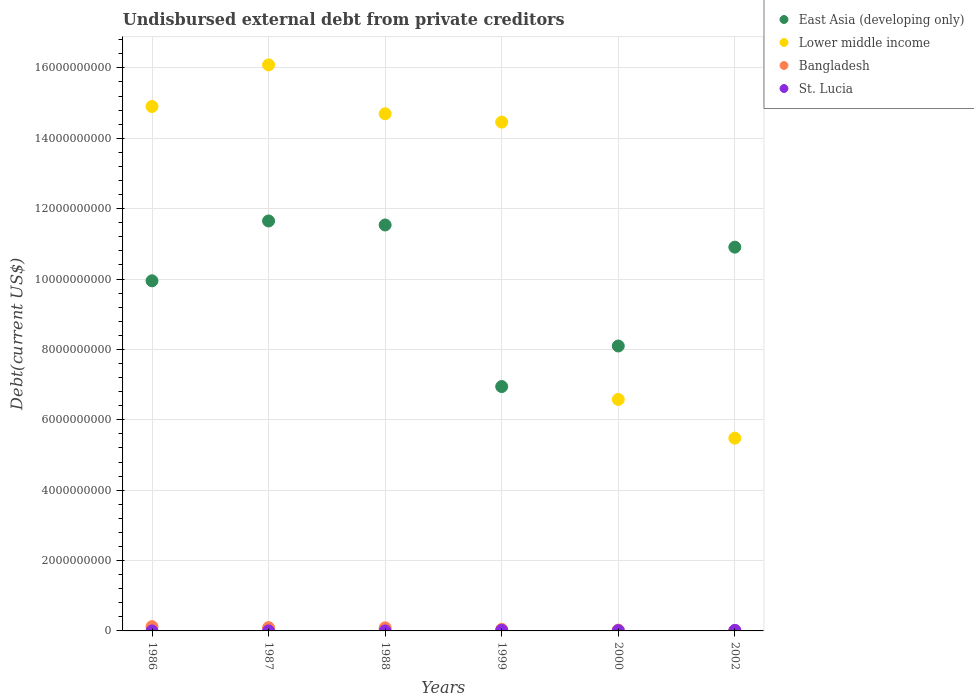How many different coloured dotlines are there?
Give a very brief answer. 4. Is the number of dotlines equal to the number of legend labels?
Give a very brief answer. Yes. What is the total debt in St. Lucia in 1987?
Your answer should be very brief. 4.15e+05. Across all years, what is the maximum total debt in St. Lucia?
Provide a short and direct response. 1.74e+07. Across all years, what is the minimum total debt in Lower middle income?
Your answer should be compact. 5.48e+09. What is the total total debt in Lower middle income in the graph?
Your answer should be compact. 7.22e+1. What is the difference between the total debt in Bangladesh in 1988 and that in 2000?
Make the answer very short. 6.29e+07. What is the difference between the total debt in Lower middle income in 1988 and the total debt in St. Lucia in 1986?
Provide a short and direct response. 1.47e+1. What is the average total debt in St. Lucia per year?
Provide a succinct answer. 7.09e+06. In the year 1999, what is the difference between the total debt in St. Lucia and total debt in Lower middle income?
Make the answer very short. -1.44e+1. What is the ratio of the total debt in St. Lucia in 1986 to that in 1988?
Keep it short and to the point. 0.81. What is the difference between the highest and the second highest total debt in Bangladesh?
Make the answer very short. 2.77e+07. What is the difference between the highest and the lowest total debt in East Asia (developing only)?
Offer a terse response. 4.71e+09. In how many years, is the total debt in St. Lucia greater than the average total debt in St. Lucia taken over all years?
Offer a very short reply. 3. Is the sum of the total debt in Lower middle income in 1986 and 2002 greater than the maximum total debt in East Asia (developing only) across all years?
Offer a terse response. Yes. Is it the case that in every year, the sum of the total debt in St. Lucia and total debt in Lower middle income  is greater than the total debt in East Asia (developing only)?
Provide a succinct answer. No. Is the total debt in East Asia (developing only) strictly less than the total debt in Lower middle income over the years?
Provide a succinct answer. No. What is the difference between two consecutive major ticks on the Y-axis?
Give a very brief answer. 2.00e+09. Are the values on the major ticks of Y-axis written in scientific E-notation?
Your response must be concise. No. Does the graph contain grids?
Make the answer very short. Yes. How are the legend labels stacked?
Provide a short and direct response. Vertical. What is the title of the graph?
Keep it short and to the point. Undisbursed external debt from private creditors. Does "St. Kitts and Nevis" appear as one of the legend labels in the graph?
Your response must be concise. No. What is the label or title of the Y-axis?
Make the answer very short. Debt(current US$). What is the Debt(current US$) of East Asia (developing only) in 1986?
Make the answer very short. 9.95e+09. What is the Debt(current US$) of Lower middle income in 1986?
Provide a succinct answer. 1.49e+1. What is the Debt(current US$) of Bangladesh in 1986?
Provide a short and direct response. 1.21e+08. What is the Debt(current US$) in St. Lucia in 1986?
Offer a terse response. 3.27e+05. What is the Debt(current US$) of East Asia (developing only) in 1987?
Your answer should be very brief. 1.16e+1. What is the Debt(current US$) of Lower middle income in 1987?
Your response must be concise. 1.61e+1. What is the Debt(current US$) of Bangladesh in 1987?
Offer a terse response. 9.33e+07. What is the Debt(current US$) of St. Lucia in 1987?
Your response must be concise. 4.15e+05. What is the Debt(current US$) of East Asia (developing only) in 1988?
Keep it short and to the point. 1.15e+1. What is the Debt(current US$) in Lower middle income in 1988?
Offer a terse response. 1.47e+1. What is the Debt(current US$) of Bangladesh in 1988?
Ensure brevity in your answer.  8.73e+07. What is the Debt(current US$) in St. Lucia in 1988?
Provide a succinct answer. 4.02e+05. What is the Debt(current US$) of East Asia (developing only) in 1999?
Provide a short and direct response. 6.94e+09. What is the Debt(current US$) of Lower middle income in 1999?
Your answer should be very brief. 1.45e+1. What is the Debt(current US$) in Bangladesh in 1999?
Your response must be concise. 4.35e+07. What is the Debt(current US$) of St. Lucia in 1999?
Offer a very short reply. 1.74e+07. What is the Debt(current US$) of East Asia (developing only) in 2000?
Keep it short and to the point. 8.10e+09. What is the Debt(current US$) of Lower middle income in 2000?
Offer a very short reply. 6.58e+09. What is the Debt(current US$) of Bangladesh in 2000?
Offer a very short reply. 2.44e+07. What is the Debt(current US$) in St. Lucia in 2000?
Provide a short and direct response. 9.00e+06. What is the Debt(current US$) in East Asia (developing only) in 2002?
Give a very brief answer. 1.09e+1. What is the Debt(current US$) of Lower middle income in 2002?
Ensure brevity in your answer.  5.48e+09. What is the Debt(current US$) in Bangladesh in 2002?
Keep it short and to the point. 1.15e+07. What is the Debt(current US$) in St. Lucia in 2002?
Give a very brief answer. 1.50e+07. Across all years, what is the maximum Debt(current US$) in East Asia (developing only)?
Give a very brief answer. 1.16e+1. Across all years, what is the maximum Debt(current US$) of Lower middle income?
Your answer should be very brief. 1.61e+1. Across all years, what is the maximum Debt(current US$) of Bangladesh?
Keep it short and to the point. 1.21e+08. Across all years, what is the maximum Debt(current US$) of St. Lucia?
Give a very brief answer. 1.74e+07. Across all years, what is the minimum Debt(current US$) of East Asia (developing only)?
Make the answer very short. 6.94e+09. Across all years, what is the minimum Debt(current US$) of Lower middle income?
Provide a succinct answer. 5.48e+09. Across all years, what is the minimum Debt(current US$) of Bangladesh?
Provide a succinct answer. 1.15e+07. Across all years, what is the minimum Debt(current US$) in St. Lucia?
Keep it short and to the point. 3.27e+05. What is the total Debt(current US$) in East Asia (developing only) in the graph?
Keep it short and to the point. 5.91e+1. What is the total Debt(current US$) of Lower middle income in the graph?
Ensure brevity in your answer.  7.22e+1. What is the total Debt(current US$) of Bangladesh in the graph?
Ensure brevity in your answer.  3.81e+08. What is the total Debt(current US$) in St. Lucia in the graph?
Keep it short and to the point. 4.25e+07. What is the difference between the Debt(current US$) of East Asia (developing only) in 1986 and that in 1987?
Your response must be concise. -1.70e+09. What is the difference between the Debt(current US$) of Lower middle income in 1986 and that in 1987?
Your response must be concise. -1.18e+09. What is the difference between the Debt(current US$) in Bangladesh in 1986 and that in 1987?
Provide a succinct answer. 2.77e+07. What is the difference between the Debt(current US$) in St. Lucia in 1986 and that in 1987?
Offer a very short reply. -8.80e+04. What is the difference between the Debt(current US$) in East Asia (developing only) in 1986 and that in 1988?
Offer a very short reply. -1.59e+09. What is the difference between the Debt(current US$) of Lower middle income in 1986 and that in 1988?
Provide a short and direct response. 2.07e+08. What is the difference between the Debt(current US$) in Bangladesh in 1986 and that in 1988?
Give a very brief answer. 3.37e+07. What is the difference between the Debt(current US$) in St. Lucia in 1986 and that in 1988?
Make the answer very short. -7.50e+04. What is the difference between the Debt(current US$) in East Asia (developing only) in 1986 and that in 1999?
Offer a terse response. 3.00e+09. What is the difference between the Debt(current US$) in Lower middle income in 1986 and that in 1999?
Offer a terse response. 4.43e+08. What is the difference between the Debt(current US$) of Bangladesh in 1986 and that in 1999?
Your response must be concise. 7.75e+07. What is the difference between the Debt(current US$) of St. Lucia in 1986 and that in 1999?
Make the answer very short. -1.71e+07. What is the difference between the Debt(current US$) of East Asia (developing only) in 1986 and that in 2000?
Keep it short and to the point. 1.85e+09. What is the difference between the Debt(current US$) of Lower middle income in 1986 and that in 2000?
Your answer should be very brief. 8.32e+09. What is the difference between the Debt(current US$) in Bangladesh in 1986 and that in 2000?
Ensure brevity in your answer.  9.66e+07. What is the difference between the Debt(current US$) of St. Lucia in 1986 and that in 2000?
Make the answer very short. -8.67e+06. What is the difference between the Debt(current US$) of East Asia (developing only) in 1986 and that in 2002?
Offer a very short reply. -9.57e+08. What is the difference between the Debt(current US$) in Lower middle income in 1986 and that in 2002?
Provide a succinct answer. 9.42e+09. What is the difference between the Debt(current US$) of Bangladesh in 1986 and that in 2002?
Give a very brief answer. 1.09e+08. What is the difference between the Debt(current US$) of St. Lucia in 1986 and that in 2002?
Ensure brevity in your answer.  -1.47e+07. What is the difference between the Debt(current US$) in East Asia (developing only) in 1987 and that in 1988?
Make the answer very short. 1.14e+08. What is the difference between the Debt(current US$) of Lower middle income in 1987 and that in 1988?
Ensure brevity in your answer.  1.39e+09. What is the difference between the Debt(current US$) of St. Lucia in 1987 and that in 1988?
Provide a succinct answer. 1.30e+04. What is the difference between the Debt(current US$) of East Asia (developing only) in 1987 and that in 1999?
Provide a succinct answer. 4.71e+09. What is the difference between the Debt(current US$) in Lower middle income in 1987 and that in 1999?
Provide a succinct answer. 1.63e+09. What is the difference between the Debt(current US$) in Bangladesh in 1987 and that in 1999?
Offer a very short reply. 4.98e+07. What is the difference between the Debt(current US$) of St. Lucia in 1987 and that in 1999?
Ensure brevity in your answer.  -1.70e+07. What is the difference between the Debt(current US$) of East Asia (developing only) in 1987 and that in 2000?
Ensure brevity in your answer.  3.55e+09. What is the difference between the Debt(current US$) of Lower middle income in 1987 and that in 2000?
Offer a terse response. 9.51e+09. What is the difference between the Debt(current US$) in Bangladesh in 1987 and that in 2000?
Your response must be concise. 6.89e+07. What is the difference between the Debt(current US$) in St. Lucia in 1987 and that in 2000?
Give a very brief answer. -8.58e+06. What is the difference between the Debt(current US$) of East Asia (developing only) in 1987 and that in 2002?
Make the answer very short. 7.45e+08. What is the difference between the Debt(current US$) in Lower middle income in 1987 and that in 2002?
Offer a very short reply. 1.06e+1. What is the difference between the Debt(current US$) in Bangladesh in 1987 and that in 2002?
Your answer should be very brief. 8.18e+07. What is the difference between the Debt(current US$) of St. Lucia in 1987 and that in 2002?
Make the answer very short. -1.46e+07. What is the difference between the Debt(current US$) of East Asia (developing only) in 1988 and that in 1999?
Offer a terse response. 4.59e+09. What is the difference between the Debt(current US$) in Lower middle income in 1988 and that in 1999?
Provide a short and direct response. 2.37e+08. What is the difference between the Debt(current US$) of Bangladesh in 1988 and that in 1999?
Offer a very short reply. 4.38e+07. What is the difference between the Debt(current US$) of St. Lucia in 1988 and that in 1999?
Keep it short and to the point. -1.70e+07. What is the difference between the Debt(current US$) of East Asia (developing only) in 1988 and that in 2000?
Your answer should be compact. 3.44e+09. What is the difference between the Debt(current US$) of Lower middle income in 1988 and that in 2000?
Your response must be concise. 8.12e+09. What is the difference between the Debt(current US$) of Bangladesh in 1988 and that in 2000?
Offer a very short reply. 6.29e+07. What is the difference between the Debt(current US$) in St. Lucia in 1988 and that in 2000?
Your answer should be compact. -8.60e+06. What is the difference between the Debt(current US$) in East Asia (developing only) in 1988 and that in 2002?
Keep it short and to the point. 6.30e+08. What is the difference between the Debt(current US$) in Lower middle income in 1988 and that in 2002?
Your answer should be compact. 9.22e+09. What is the difference between the Debt(current US$) of Bangladesh in 1988 and that in 2002?
Offer a terse response. 7.58e+07. What is the difference between the Debt(current US$) of St. Lucia in 1988 and that in 2002?
Your response must be concise. -1.46e+07. What is the difference between the Debt(current US$) of East Asia (developing only) in 1999 and that in 2000?
Your response must be concise. -1.15e+09. What is the difference between the Debt(current US$) of Lower middle income in 1999 and that in 2000?
Your answer should be compact. 7.88e+09. What is the difference between the Debt(current US$) in Bangladesh in 1999 and that in 2000?
Your answer should be very brief. 1.91e+07. What is the difference between the Debt(current US$) in St. Lucia in 1999 and that in 2000?
Your answer should be compact. 8.40e+06. What is the difference between the Debt(current US$) in East Asia (developing only) in 1999 and that in 2002?
Keep it short and to the point. -3.96e+09. What is the difference between the Debt(current US$) in Lower middle income in 1999 and that in 2002?
Keep it short and to the point. 8.98e+09. What is the difference between the Debt(current US$) of Bangladesh in 1999 and that in 2002?
Make the answer very short. 3.20e+07. What is the difference between the Debt(current US$) of St. Lucia in 1999 and that in 2002?
Provide a succinct answer. 2.40e+06. What is the difference between the Debt(current US$) of East Asia (developing only) in 2000 and that in 2002?
Your answer should be compact. -2.81e+09. What is the difference between the Debt(current US$) in Lower middle income in 2000 and that in 2002?
Give a very brief answer. 1.10e+09. What is the difference between the Debt(current US$) in Bangladesh in 2000 and that in 2002?
Your answer should be compact. 1.29e+07. What is the difference between the Debt(current US$) of St. Lucia in 2000 and that in 2002?
Ensure brevity in your answer.  -6.00e+06. What is the difference between the Debt(current US$) in East Asia (developing only) in 1986 and the Debt(current US$) in Lower middle income in 1987?
Your answer should be compact. -6.14e+09. What is the difference between the Debt(current US$) in East Asia (developing only) in 1986 and the Debt(current US$) in Bangladesh in 1987?
Offer a terse response. 9.86e+09. What is the difference between the Debt(current US$) in East Asia (developing only) in 1986 and the Debt(current US$) in St. Lucia in 1987?
Ensure brevity in your answer.  9.95e+09. What is the difference between the Debt(current US$) in Lower middle income in 1986 and the Debt(current US$) in Bangladesh in 1987?
Your answer should be very brief. 1.48e+1. What is the difference between the Debt(current US$) in Lower middle income in 1986 and the Debt(current US$) in St. Lucia in 1987?
Make the answer very short. 1.49e+1. What is the difference between the Debt(current US$) in Bangladesh in 1986 and the Debt(current US$) in St. Lucia in 1987?
Provide a short and direct response. 1.21e+08. What is the difference between the Debt(current US$) of East Asia (developing only) in 1986 and the Debt(current US$) of Lower middle income in 1988?
Make the answer very short. -4.75e+09. What is the difference between the Debt(current US$) in East Asia (developing only) in 1986 and the Debt(current US$) in Bangladesh in 1988?
Your answer should be very brief. 9.86e+09. What is the difference between the Debt(current US$) of East Asia (developing only) in 1986 and the Debt(current US$) of St. Lucia in 1988?
Your answer should be compact. 9.95e+09. What is the difference between the Debt(current US$) of Lower middle income in 1986 and the Debt(current US$) of Bangladesh in 1988?
Your answer should be compact. 1.48e+1. What is the difference between the Debt(current US$) in Lower middle income in 1986 and the Debt(current US$) in St. Lucia in 1988?
Your answer should be very brief. 1.49e+1. What is the difference between the Debt(current US$) in Bangladesh in 1986 and the Debt(current US$) in St. Lucia in 1988?
Keep it short and to the point. 1.21e+08. What is the difference between the Debt(current US$) of East Asia (developing only) in 1986 and the Debt(current US$) of Lower middle income in 1999?
Offer a very short reply. -4.51e+09. What is the difference between the Debt(current US$) of East Asia (developing only) in 1986 and the Debt(current US$) of Bangladesh in 1999?
Offer a very short reply. 9.91e+09. What is the difference between the Debt(current US$) of East Asia (developing only) in 1986 and the Debt(current US$) of St. Lucia in 1999?
Your response must be concise. 9.93e+09. What is the difference between the Debt(current US$) in Lower middle income in 1986 and the Debt(current US$) in Bangladesh in 1999?
Your response must be concise. 1.49e+1. What is the difference between the Debt(current US$) of Lower middle income in 1986 and the Debt(current US$) of St. Lucia in 1999?
Your answer should be very brief. 1.49e+1. What is the difference between the Debt(current US$) in Bangladesh in 1986 and the Debt(current US$) in St. Lucia in 1999?
Your response must be concise. 1.04e+08. What is the difference between the Debt(current US$) in East Asia (developing only) in 1986 and the Debt(current US$) in Lower middle income in 2000?
Offer a terse response. 3.37e+09. What is the difference between the Debt(current US$) in East Asia (developing only) in 1986 and the Debt(current US$) in Bangladesh in 2000?
Your answer should be compact. 9.92e+09. What is the difference between the Debt(current US$) of East Asia (developing only) in 1986 and the Debt(current US$) of St. Lucia in 2000?
Your answer should be very brief. 9.94e+09. What is the difference between the Debt(current US$) in Lower middle income in 1986 and the Debt(current US$) in Bangladesh in 2000?
Your answer should be compact. 1.49e+1. What is the difference between the Debt(current US$) in Lower middle income in 1986 and the Debt(current US$) in St. Lucia in 2000?
Provide a succinct answer. 1.49e+1. What is the difference between the Debt(current US$) of Bangladesh in 1986 and the Debt(current US$) of St. Lucia in 2000?
Offer a terse response. 1.12e+08. What is the difference between the Debt(current US$) of East Asia (developing only) in 1986 and the Debt(current US$) of Lower middle income in 2002?
Provide a short and direct response. 4.47e+09. What is the difference between the Debt(current US$) in East Asia (developing only) in 1986 and the Debt(current US$) in Bangladesh in 2002?
Make the answer very short. 9.94e+09. What is the difference between the Debt(current US$) in East Asia (developing only) in 1986 and the Debt(current US$) in St. Lucia in 2002?
Your response must be concise. 9.93e+09. What is the difference between the Debt(current US$) of Lower middle income in 1986 and the Debt(current US$) of Bangladesh in 2002?
Provide a succinct answer. 1.49e+1. What is the difference between the Debt(current US$) in Lower middle income in 1986 and the Debt(current US$) in St. Lucia in 2002?
Your answer should be compact. 1.49e+1. What is the difference between the Debt(current US$) in Bangladesh in 1986 and the Debt(current US$) in St. Lucia in 2002?
Provide a short and direct response. 1.06e+08. What is the difference between the Debt(current US$) of East Asia (developing only) in 1987 and the Debt(current US$) of Lower middle income in 1988?
Provide a short and direct response. -3.05e+09. What is the difference between the Debt(current US$) of East Asia (developing only) in 1987 and the Debt(current US$) of Bangladesh in 1988?
Your response must be concise. 1.16e+1. What is the difference between the Debt(current US$) in East Asia (developing only) in 1987 and the Debt(current US$) in St. Lucia in 1988?
Your answer should be very brief. 1.16e+1. What is the difference between the Debt(current US$) of Lower middle income in 1987 and the Debt(current US$) of Bangladesh in 1988?
Offer a terse response. 1.60e+1. What is the difference between the Debt(current US$) of Lower middle income in 1987 and the Debt(current US$) of St. Lucia in 1988?
Your answer should be compact. 1.61e+1. What is the difference between the Debt(current US$) of Bangladesh in 1987 and the Debt(current US$) of St. Lucia in 1988?
Keep it short and to the point. 9.29e+07. What is the difference between the Debt(current US$) of East Asia (developing only) in 1987 and the Debt(current US$) of Lower middle income in 1999?
Provide a short and direct response. -2.81e+09. What is the difference between the Debt(current US$) in East Asia (developing only) in 1987 and the Debt(current US$) in Bangladesh in 1999?
Provide a succinct answer. 1.16e+1. What is the difference between the Debt(current US$) of East Asia (developing only) in 1987 and the Debt(current US$) of St. Lucia in 1999?
Provide a short and direct response. 1.16e+1. What is the difference between the Debt(current US$) in Lower middle income in 1987 and the Debt(current US$) in Bangladesh in 1999?
Your response must be concise. 1.60e+1. What is the difference between the Debt(current US$) in Lower middle income in 1987 and the Debt(current US$) in St. Lucia in 1999?
Offer a terse response. 1.61e+1. What is the difference between the Debt(current US$) of Bangladesh in 1987 and the Debt(current US$) of St. Lucia in 1999?
Your answer should be very brief. 7.59e+07. What is the difference between the Debt(current US$) of East Asia (developing only) in 1987 and the Debt(current US$) of Lower middle income in 2000?
Provide a short and direct response. 5.07e+09. What is the difference between the Debt(current US$) in East Asia (developing only) in 1987 and the Debt(current US$) in Bangladesh in 2000?
Give a very brief answer. 1.16e+1. What is the difference between the Debt(current US$) of East Asia (developing only) in 1987 and the Debt(current US$) of St. Lucia in 2000?
Ensure brevity in your answer.  1.16e+1. What is the difference between the Debt(current US$) of Lower middle income in 1987 and the Debt(current US$) of Bangladesh in 2000?
Offer a very short reply. 1.61e+1. What is the difference between the Debt(current US$) in Lower middle income in 1987 and the Debt(current US$) in St. Lucia in 2000?
Provide a succinct answer. 1.61e+1. What is the difference between the Debt(current US$) of Bangladesh in 1987 and the Debt(current US$) of St. Lucia in 2000?
Offer a terse response. 8.43e+07. What is the difference between the Debt(current US$) of East Asia (developing only) in 1987 and the Debt(current US$) of Lower middle income in 2002?
Your answer should be very brief. 6.17e+09. What is the difference between the Debt(current US$) of East Asia (developing only) in 1987 and the Debt(current US$) of Bangladesh in 2002?
Provide a short and direct response. 1.16e+1. What is the difference between the Debt(current US$) of East Asia (developing only) in 1987 and the Debt(current US$) of St. Lucia in 2002?
Keep it short and to the point. 1.16e+1. What is the difference between the Debt(current US$) of Lower middle income in 1987 and the Debt(current US$) of Bangladesh in 2002?
Your answer should be compact. 1.61e+1. What is the difference between the Debt(current US$) in Lower middle income in 1987 and the Debt(current US$) in St. Lucia in 2002?
Your answer should be very brief. 1.61e+1. What is the difference between the Debt(current US$) of Bangladesh in 1987 and the Debt(current US$) of St. Lucia in 2002?
Provide a succinct answer. 7.83e+07. What is the difference between the Debt(current US$) in East Asia (developing only) in 1988 and the Debt(current US$) in Lower middle income in 1999?
Your response must be concise. -2.92e+09. What is the difference between the Debt(current US$) of East Asia (developing only) in 1988 and the Debt(current US$) of Bangladesh in 1999?
Provide a succinct answer. 1.15e+1. What is the difference between the Debt(current US$) in East Asia (developing only) in 1988 and the Debt(current US$) in St. Lucia in 1999?
Ensure brevity in your answer.  1.15e+1. What is the difference between the Debt(current US$) in Lower middle income in 1988 and the Debt(current US$) in Bangladesh in 1999?
Ensure brevity in your answer.  1.47e+1. What is the difference between the Debt(current US$) of Lower middle income in 1988 and the Debt(current US$) of St. Lucia in 1999?
Offer a very short reply. 1.47e+1. What is the difference between the Debt(current US$) in Bangladesh in 1988 and the Debt(current US$) in St. Lucia in 1999?
Offer a very short reply. 6.99e+07. What is the difference between the Debt(current US$) of East Asia (developing only) in 1988 and the Debt(current US$) of Lower middle income in 2000?
Give a very brief answer. 4.96e+09. What is the difference between the Debt(current US$) of East Asia (developing only) in 1988 and the Debt(current US$) of Bangladesh in 2000?
Offer a very short reply. 1.15e+1. What is the difference between the Debt(current US$) in East Asia (developing only) in 1988 and the Debt(current US$) in St. Lucia in 2000?
Make the answer very short. 1.15e+1. What is the difference between the Debt(current US$) of Lower middle income in 1988 and the Debt(current US$) of Bangladesh in 2000?
Provide a succinct answer. 1.47e+1. What is the difference between the Debt(current US$) of Lower middle income in 1988 and the Debt(current US$) of St. Lucia in 2000?
Your answer should be very brief. 1.47e+1. What is the difference between the Debt(current US$) of Bangladesh in 1988 and the Debt(current US$) of St. Lucia in 2000?
Keep it short and to the point. 7.83e+07. What is the difference between the Debt(current US$) of East Asia (developing only) in 1988 and the Debt(current US$) of Lower middle income in 2002?
Provide a short and direct response. 6.06e+09. What is the difference between the Debt(current US$) of East Asia (developing only) in 1988 and the Debt(current US$) of Bangladesh in 2002?
Provide a succinct answer. 1.15e+1. What is the difference between the Debt(current US$) in East Asia (developing only) in 1988 and the Debt(current US$) in St. Lucia in 2002?
Give a very brief answer. 1.15e+1. What is the difference between the Debt(current US$) in Lower middle income in 1988 and the Debt(current US$) in Bangladesh in 2002?
Your answer should be very brief. 1.47e+1. What is the difference between the Debt(current US$) in Lower middle income in 1988 and the Debt(current US$) in St. Lucia in 2002?
Offer a very short reply. 1.47e+1. What is the difference between the Debt(current US$) of Bangladesh in 1988 and the Debt(current US$) of St. Lucia in 2002?
Offer a terse response. 7.23e+07. What is the difference between the Debt(current US$) of East Asia (developing only) in 1999 and the Debt(current US$) of Lower middle income in 2000?
Your answer should be very brief. 3.66e+08. What is the difference between the Debt(current US$) of East Asia (developing only) in 1999 and the Debt(current US$) of Bangladesh in 2000?
Make the answer very short. 6.92e+09. What is the difference between the Debt(current US$) of East Asia (developing only) in 1999 and the Debt(current US$) of St. Lucia in 2000?
Give a very brief answer. 6.94e+09. What is the difference between the Debt(current US$) of Lower middle income in 1999 and the Debt(current US$) of Bangladesh in 2000?
Your answer should be compact. 1.44e+1. What is the difference between the Debt(current US$) of Lower middle income in 1999 and the Debt(current US$) of St. Lucia in 2000?
Provide a succinct answer. 1.45e+1. What is the difference between the Debt(current US$) of Bangladesh in 1999 and the Debt(current US$) of St. Lucia in 2000?
Provide a succinct answer. 3.45e+07. What is the difference between the Debt(current US$) in East Asia (developing only) in 1999 and the Debt(current US$) in Lower middle income in 2002?
Keep it short and to the point. 1.47e+09. What is the difference between the Debt(current US$) in East Asia (developing only) in 1999 and the Debt(current US$) in Bangladesh in 2002?
Keep it short and to the point. 6.93e+09. What is the difference between the Debt(current US$) in East Asia (developing only) in 1999 and the Debt(current US$) in St. Lucia in 2002?
Provide a succinct answer. 6.93e+09. What is the difference between the Debt(current US$) of Lower middle income in 1999 and the Debt(current US$) of Bangladesh in 2002?
Give a very brief answer. 1.44e+1. What is the difference between the Debt(current US$) of Lower middle income in 1999 and the Debt(current US$) of St. Lucia in 2002?
Provide a succinct answer. 1.44e+1. What is the difference between the Debt(current US$) in Bangladesh in 1999 and the Debt(current US$) in St. Lucia in 2002?
Provide a short and direct response. 2.85e+07. What is the difference between the Debt(current US$) in East Asia (developing only) in 2000 and the Debt(current US$) in Lower middle income in 2002?
Offer a very short reply. 2.62e+09. What is the difference between the Debt(current US$) of East Asia (developing only) in 2000 and the Debt(current US$) of Bangladesh in 2002?
Make the answer very short. 8.09e+09. What is the difference between the Debt(current US$) of East Asia (developing only) in 2000 and the Debt(current US$) of St. Lucia in 2002?
Your answer should be compact. 8.08e+09. What is the difference between the Debt(current US$) in Lower middle income in 2000 and the Debt(current US$) in Bangladesh in 2002?
Offer a terse response. 6.57e+09. What is the difference between the Debt(current US$) in Lower middle income in 2000 and the Debt(current US$) in St. Lucia in 2002?
Keep it short and to the point. 6.56e+09. What is the difference between the Debt(current US$) of Bangladesh in 2000 and the Debt(current US$) of St. Lucia in 2002?
Provide a short and direct response. 9.43e+06. What is the average Debt(current US$) of East Asia (developing only) per year?
Keep it short and to the point. 9.85e+09. What is the average Debt(current US$) of Lower middle income per year?
Provide a succinct answer. 1.20e+1. What is the average Debt(current US$) in Bangladesh per year?
Your answer should be very brief. 6.35e+07. What is the average Debt(current US$) in St. Lucia per year?
Offer a very short reply. 7.09e+06. In the year 1986, what is the difference between the Debt(current US$) of East Asia (developing only) and Debt(current US$) of Lower middle income?
Provide a succinct answer. -4.95e+09. In the year 1986, what is the difference between the Debt(current US$) in East Asia (developing only) and Debt(current US$) in Bangladesh?
Provide a short and direct response. 9.83e+09. In the year 1986, what is the difference between the Debt(current US$) of East Asia (developing only) and Debt(current US$) of St. Lucia?
Ensure brevity in your answer.  9.95e+09. In the year 1986, what is the difference between the Debt(current US$) of Lower middle income and Debt(current US$) of Bangladesh?
Your answer should be compact. 1.48e+1. In the year 1986, what is the difference between the Debt(current US$) in Lower middle income and Debt(current US$) in St. Lucia?
Provide a succinct answer. 1.49e+1. In the year 1986, what is the difference between the Debt(current US$) of Bangladesh and Debt(current US$) of St. Lucia?
Your response must be concise. 1.21e+08. In the year 1987, what is the difference between the Debt(current US$) in East Asia (developing only) and Debt(current US$) in Lower middle income?
Offer a very short reply. -4.44e+09. In the year 1987, what is the difference between the Debt(current US$) in East Asia (developing only) and Debt(current US$) in Bangladesh?
Offer a very short reply. 1.16e+1. In the year 1987, what is the difference between the Debt(current US$) of East Asia (developing only) and Debt(current US$) of St. Lucia?
Make the answer very short. 1.16e+1. In the year 1987, what is the difference between the Debt(current US$) of Lower middle income and Debt(current US$) of Bangladesh?
Your answer should be very brief. 1.60e+1. In the year 1987, what is the difference between the Debt(current US$) in Lower middle income and Debt(current US$) in St. Lucia?
Offer a terse response. 1.61e+1. In the year 1987, what is the difference between the Debt(current US$) of Bangladesh and Debt(current US$) of St. Lucia?
Provide a short and direct response. 9.29e+07. In the year 1988, what is the difference between the Debt(current US$) in East Asia (developing only) and Debt(current US$) in Lower middle income?
Give a very brief answer. -3.16e+09. In the year 1988, what is the difference between the Debt(current US$) in East Asia (developing only) and Debt(current US$) in Bangladesh?
Ensure brevity in your answer.  1.14e+1. In the year 1988, what is the difference between the Debt(current US$) of East Asia (developing only) and Debt(current US$) of St. Lucia?
Offer a very short reply. 1.15e+1. In the year 1988, what is the difference between the Debt(current US$) of Lower middle income and Debt(current US$) of Bangladesh?
Ensure brevity in your answer.  1.46e+1. In the year 1988, what is the difference between the Debt(current US$) of Lower middle income and Debt(current US$) of St. Lucia?
Your answer should be compact. 1.47e+1. In the year 1988, what is the difference between the Debt(current US$) in Bangladesh and Debt(current US$) in St. Lucia?
Your response must be concise. 8.69e+07. In the year 1999, what is the difference between the Debt(current US$) of East Asia (developing only) and Debt(current US$) of Lower middle income?
Your response must be concise. -7.52e+09. In the year 1999, what is the difference between the Debt(current US$) of East Asia (developing only) and Debt(current US$) of Bangladesh?
Your response must be concise. 6.90e+09. In the year 1999, what is the difference between the Debt(current US$) of East Asia (developing only) and Debt(current US$) of St. Lucia?
Offer a terse response. 6.93e+09. In the year 1999, what is the difference between the Debt(current US$) of Lower middle income and Debt(current US$) of Bangladesh?
Provide a short and direct response. 1.44e+1. In the year 1999, what is the difference between the Debt(current US$) of Lower middle income and Debt(current US$) of St. Lucia?
Keep it short and to the point. 1.44e+1. In the year 1999, what is the difference between the Debt(current US$) of Bangladesh and Debt(current US$) of St. Lucia?
Your answer should be very brief. 2.61e+07. In the year 2000, what is the difference between the Debt(current US$) of East Asia (developing only) and Debt(current US$) of Lower middle income?
Provide a succinct answer. 1.52e+09. In the year 2000, what is the difference between the Debt(current US$) in East Asia (developing only) and Debt(current US$) in Bangladesh?
Give a very brief answer. 8.07e+09. In the year 2000, what is the difference between the Debt(current US$) in East Asia (developing only) and Debt(current US$) in St. Lucia?
Your response must be concise. 8.09e+09. In the year 2000, what is the difference between the Debt(current US$) of Lower middle income and Debt(current US$) of Bangladesh?
Offer a terse response. 6.55e+09. In the year 2000, what is the difference between the Debt(current US$) of Lower middle income and Debt(current US$) of St. Lucia?
Ensure brevity in your answer.  6.57e+09. In the year 2000, what is the difference between the Debt(current US$) in Bangladesh and Debt(current US$) in St. Lucia?
Your response must be concise. 1.54e+07. In the year 2002, what is the difference between the Debt(current US$) in East Asia (developing only) and Debt(current US$) in Lower middle income?
Provide a succinct answer. 5.43e+09. In the year 2002, what is the difference between the Debt(current US$) of East Asia (developing only) and Debt(current US$) of Bangladesh?
Offer a very short reply. 1.09e+1. In the year 2002, what is the difference between the Debt(current US$) of East Asia (developing only) and Debt(current US$) of St. Lucia?
Offer a very short reply. 1.09e+1. In the year 2002, what is the difference between the Debt(current US$) in Lower middle income and Debt(current US$) in Bangladesh?
Your answer should be compact. 5.47e+09. In the year 2002, what is the difference between the Debt(current US$) in Lower middle income and Debt(current US$) in St. Lucia?
Provide a succinct answer. 5.46e+09. In the year 2002, what is the difference between the Debt(current US$) in Bangladesh and Debt(current US$) in St. Lucia?
Your answer should be very brief. -3.47e+06. What is the ratio of the Debt(current US$) in East Asia (developing only) in 1986 to that in 1987?
Your response must be concise. 0.85. What is the ratio of the Debt(current US$) of Lower middle income in 1986 to that in 1987?
Your answer should be compact. 0.93. What is the ratio of the Debt(current US$) in Bangladesh in 1986 to that in 1987?
Provide a short and direct response. 1.3. What is the ratio of the Debt(current US$) of St. Lucia in 1986 to that in 1987?
Provide a succinct answer. 0.79. What is the ratio of the Debt(current US$) in East Asia (developing only) in 1986 to that in 1988?
Your answer should be very brief. 0.86. What is the ratio of the Debt(current US$) of Lower middle income in 1986 to that in 1988?
Provide a succinct answer. 1.01. What is the ratio of the Debt(current US$) in Bangladesh in 1986 to that in 1988?
Provide a short and direct response. 1.39. What is the ratio of the Debt(current US$) of St. Lucia in 1986 to that in 1988?
Your response must be concise. 0.81. What is the ratio of the Debt(current US$) of East Asia (developing only) in 1986 to that in 1999?
Your response must be concise. 1.43. What is the ratio of the Debt(current US$) of Lower middle income in 1986 to that in 1999?
Give a very brief answer. 1.03. What is the ratio of the Debt(current US$) of Bangladesh in 1986 to that in 1999?
Offer a very short reply. 2.78. What is the ratio of the Debt(current US$) in St. Lucia in 1986 to that in 1999?
Provide a succinct answer. 0.02. What is the ratio of the Debt(current US$) of East Asia (developing only) in 1986 to that in 2000?
Offer a terse response. 1.23. What is the ratio of the Debt(current US$) of Lower middle income in 1986 to that in 2000?
Offer a very short reply. 2.27. What is the ratio of the Debt(current US$) of Bangladesh in 1986 to that in 2000?
Give a very brief answer. 4.95. What is the ratio of the Debt(current US$) of St. Lucia in 1986 to that in 2000?
Offer a very short reply. 0.04. What is the ratio of the Debt(current US$) of East Asia (developing only) in 1986 to that in 2002?
Keep it short and to the point. 0.91. What is the ratio of the Debt(current US$) of Lower middle income in 1986 to that in 2002?
Provide a short and direct response. 2.72. What is the ratio of the Debt(current US$) in Bangladesh in 1986 to that in 2002?
Your response must be concise. 10.49. What is the ratio of the Debt(current US$) of St. Lucia in 1986 to that in 2002?
Ensure brevity in your answer.  0.02. What is the ratio of the Debt(current US$) in East Asia (developing only) in 1987 to that in 1988?
Your answer should be very brief. 1.01. What is the ratio of the Debt(current US$) of Lower middle income in 1987 to that in 1988?
Your answer should be very brief. 1.09. What is the ratio of the Debt(current US$) in Bangladesh in 1987 to that in 1988?
Provide a short and direct response. 1.07. What is the ratio of the Debt(current US$) in St. Lucia in 1987 to that in 1988?
Your response must be concise. 1.03. What is the ratio of the Debt(current US$) in East Asia (developing only) in 1987 to that in 1999?
Ensure brevity in your answer.  1.68. What is the ratio of the Debt(current US$) of Lower middle income in 1987 to that in 1999?
Your answer should be very brief. 1.11. What is the ratio of the Debt(current US$) of Bangladesh in 1987 to that in 1999?
Your answer should be compact. 2.14. What is the ratio of the Debt(current US$) of St. Lucia in 1987 to that in 1999?
Ensure brevity in your answer.  0.02. What is the ratio of the Debt(current US$) in East Asia (developing only) in 1987 to that in 2000?
Provide a succinct answer. 1.44. What is the ratio of the Debt(current US$) of Lower middle income in 1987 to that in 2000?
Keep it short and to the point. 2.45. What is the ratio of the Debt(current US$) in Bangladesh in 1987 to that in 2000?
Your response must be concise. 3.82. What is the ratio of the Debt(current US$) in St. Lucia in 1987 to that in 2000?
Ensure brevity in your answer.  0.05. What is the ratio of the Debt(current US$) in East Asia (developing only) in 1987 to that in 2002?
Give a very brief answer. 1.07. What is the ratio of the Debt(current US$) of Lower middle income in 1987 to that in 2002?
Provide a succinct answer. 2.94. What is the ratio of the Debt(current US$) in Bangladesh in 1987 to that in 2002?
Offer a terse response. 8.09. What is the ratio of the Debt(current US$) of St. Lucia in 1987 to that in 2002?
Provide a succinct answer. 0.03. What is the ratio of the Debt(current US$) of East Asia (developing only) in 1988 to that in 1999?
Your answer should be very brief. 1.66. What is the ratio of the Debt(current US$) of Lower middle income in 1988 to that in 1999?
Keep it short and to the point. 1.02. What is the ratio of the Debt(current US$) of Bangladesh in 1988 to that in 1999?
Offer a terse response. 2.01. What is the ratio of the Debt(current US$) in St. Lucia in 1988 to that in 1999?
Your response must be concise. 0.02. What is the ratio of the Debt(current US$) of East Asia (developing only) in 1988 to that in 2000?
Your answer should be very brief. 1.42. What is the ratio of the Debt(current US$) of Lower middle income in 1988 to that in 2000?
Ensure brevity in your answer.  2.23. What is the ratio of the Debt(current US$) of Bangladesh in 1988 to that in 2000?
Your answer should be compact. 3.57. What is the ratio of the Debt(current US$) of St. Lucia in 1988 to that in 2000?
Make the answer very short. 0.04. What is the ratio of the Debt(current US$) of East Asia (developing only) in 1988 to that in 2002?
Keep it short and to the point. 1.06. What is the ratio of the Debt(current US$) of Lower middle income in 1988 to that in 2002?
Offer a terse response. 2.68. What is the ratio of the Debt(current US$) in Bangladesh in 1988 to that in 2002?
Keep it short and to the point. 7.57. What is the ratio of the Debt(current US$) of St. Lucia in 1988 to that in 2002?
Provide a short and direct response. 0.03. What is the ratio of the Debt(current US$) in East Asia (developing only) in 1999 to that in 2000?
Your response must be concise. 0.86. What is the ratio of the Debt(current US$) in Lower middle income in 1999 to that in 2000?
Keep it short and to the point. 2.2. What is the ratio of the Debt(current US$) of Bangladesh in 1999 to that in 2000?
Ensure brevity in your answer.  1.78. What is the ratio of the Debt(current US$) in St. Lucia in 1999 to that in 2000?
Ensure brevity in your answer.  1.93. What is the ratio of the Debt(current US$) of East Asia (developing only) in 1999 to that in 2002?
Your answer should be very brief. 0.64. What is the ratio of the Debt(current US$) of Lower middle income in 1999 to that in 2002?
Offer a very short reply. 2.64. What is the ratio of the Debt(current US$) in Bangladesh in 1999 to that in 2002?
Give a very brief answer. 3.78. What is the ratio of the Debt(current US$) of St. Lucia in 1999 to that in 2002?
Offer a very short reply. 1.16. What is the ratio of the Debt(current US$) in East Asia (developing only) in 2000 to that in 2002?
Your response must be concise. 0.74. What is the ratio of the Debt(current US$) in Lower middle income in 2000 to that in 2002?
Offer a very short reply. 1.2. What is the ratio of the Debt(current US$) of Bangladesh in 2000 to that in 2002?
Provide a short and direct response. 2.12. What is the ratio of the Debt(current US$) of St. Lucia in 2000 to that in 2002?
Ensure brevity in your answer.  0.6. What is the difference between the highest and the second highest Debt(current US$) of East Asia (developing only)?
Your response must be concise. 1.14e+08. What is the difference between the highest and the second highest Debt(current US$) of Lower middle income?
Offer a very short reply. 1.18e+09. What is the difference between the highest and the second highest Debt(current US$) of Bangladesh?
Offer a terse response. 2.77e+07. What is the difference between the highest and the second highest Debt(current US$) of St. Lucia?
Offer a very short reply. 2.40e+06. What is the difference between the highest and the lowest Debt(current US$) of East Asia (developing only)?
Provide a short and direct response. 4.71e+09. What is the difference between the highest and the lowest Debt(current US$) of Lower middle income?
Ensure brevity in your answer.  1.06e+1. What is the difference between the highest and the lowest Debt(current US$) in Bangladesh?
Make the answer very short. 1.09e+08. What is the difference between the highest and the lowest Debt(current US$) of St. Lucia?
Ensure brevity in your answer.  1.71e+07. 